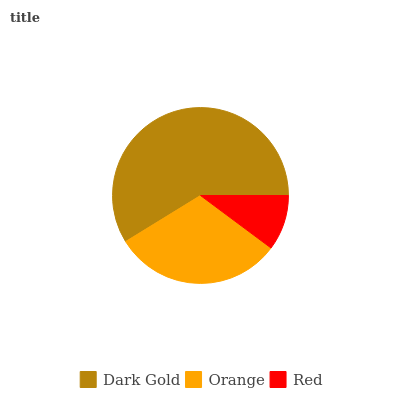Is Red the minimum?
Answer yes or no. Yes. Is Dark Gold the maximum?
Answer yes or no. Yes. Is Orange the minimum?
Answer yes or no. No. Is Orange the maximum?
Answer yes or no. No. Is Dark Gold greater than Orange?
Answer yes or no. Yes. Is Orange less than Dark Gold?
Answer yes or no. Yes. Is Orange greater than Dark Gold?
Answer yes or no. No. Is Dark Gold less than Orange?
Answer yes or no. No. Is Orange the high median?
Answer yes or no. Yes. Is Orange the low median?
Answer yes or no. Yes. Is Red the high median?
Answer yes or no. No. Is Dark Gold the low median?
Answer yes or no. No. 